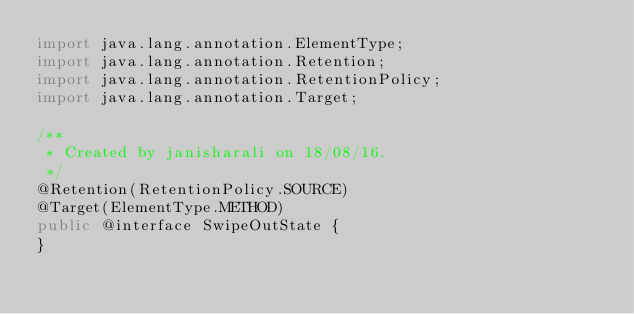<code> <loc_0><loc_0><loc_500><loc_500><_Java_>import java.lang.annotation.ElementType;
import java.lang.annotation.Retention;
import java.lang.annotation.RetentionPolicy;
import java.lang.annotation.Target;

/**
 * Created by janisharali on 18/08/16.
 */
@Retention(RetentionPolicy.SOURCE)
@Target(ElementType.METHOD)
public @interface SwipeOutState {
}
</code> 